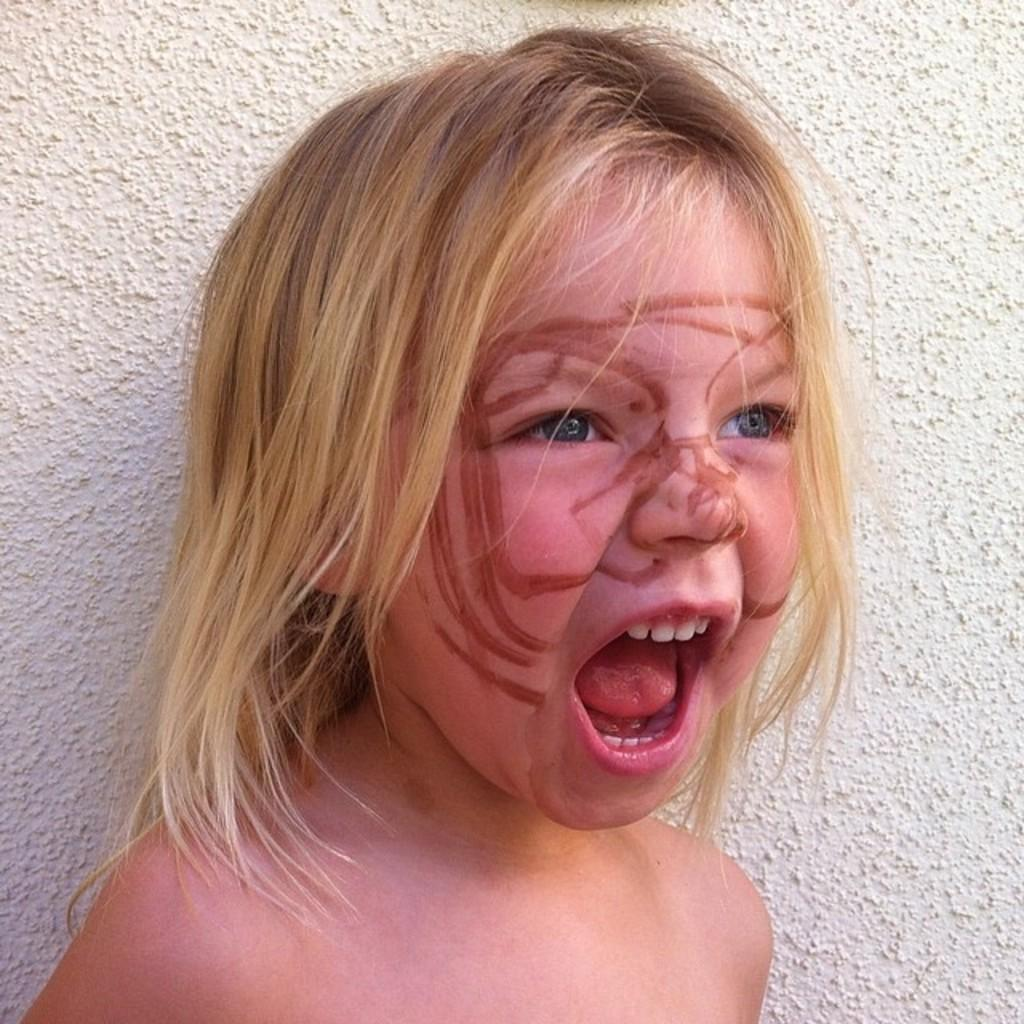Who is the main subject in the foreground of the image? There is a girl in the foreground of the image. What is the girl doing in the image? The girl has an opened mouth in the image. Are there any additional features on the girl's face? Yes, there are sketch marks on the girl's face. What can be seen in the background of the image? There is a wall in the background of the image. What type of wool is being used to create the girl's flesh in the image? There is no wool or reference to wool in the image; it is a photograph or drawing of a girl with sketch marks on her face. 